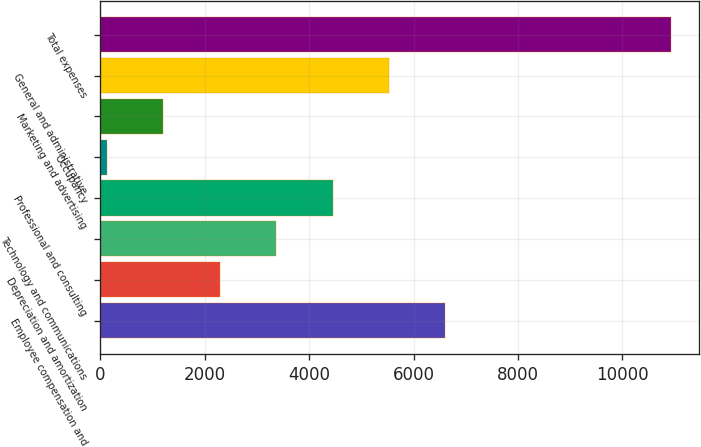<chart> <loc_0><loc_0><loc_500><loc_500><bar_chart><fcel>Employee compensation and<fcel>Depreciation and amortization<fcel>Technology and communications<fcel>Professional and consulting<fcel>Occupancy<fcel>Marketing and advertising<fcel>General and administrative<fcel>Total expenses<nl><fcel>6609.6<fcel>2291.2<fcel>3370.8<fcel>4450.4<fcel>132<fcel>1211.6<fcel>5530<fcel>10928<nl></chart> 